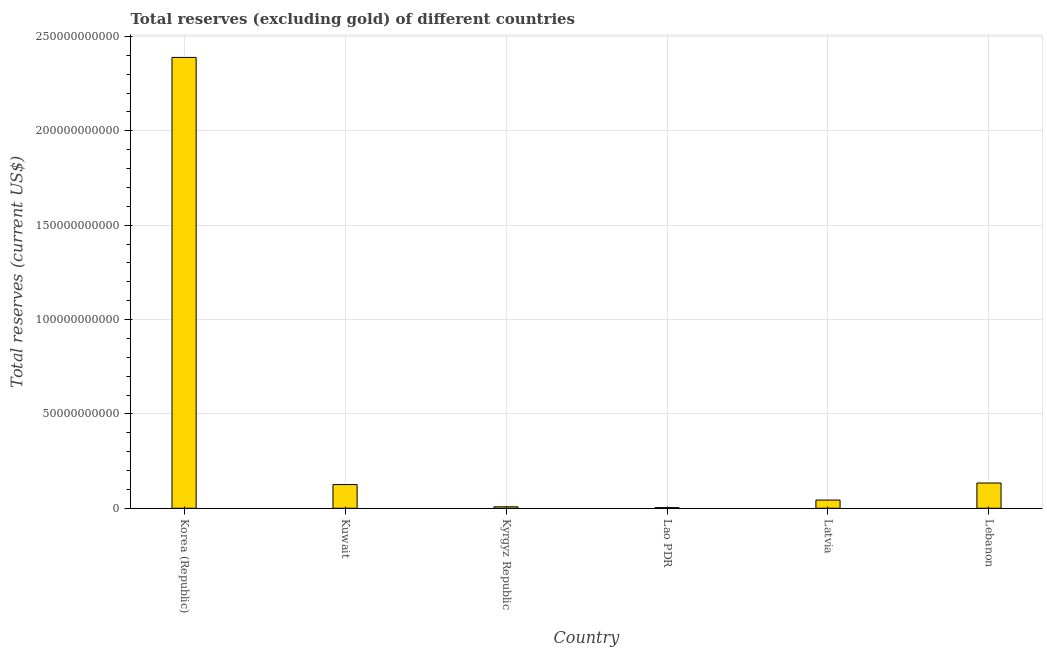Does the graph contain any zero values?
Keep it short and to the point. No. Does the graph contain grids?
Your response must be concise. Yes. What is the title of the graph?
Keep it short and to the point. Total reserves (excluding gold) of different countries. What is the label or title of the Y-axis?
Provide a short and direct response. Total reserves (current US$). What is the total reserves (excluding gold) in Korea (Republic)?
Your response must be concise. 2.39e+11. Across all countries, what is the maximum total reserves (excluding gold)?
Your answer should be very brief. 2.39e+11. Across all countries, what is the minimum total reserves (excluding gold)?
Offer a very short reply. 3.28e+08. In which country was the total reserves (excluding gold) minimum?
Make the answer very short. Lao PDR. What is the sum of the total reserves (excluding gold)?
Your answer should be very brief. 2.70e+11. What is the difference between the total reserves (excluding gold) in Kuwait and Lebanon?
Give a very brief answer. -8.10e+08. What is the average total reserves (excluding gold) per country?
Ensure brevity in your answer.  4.50e+1. What is the median total reserves (excluding gold)?
Your answer should be very brief. 8.46e+09. What is the ratio of the total reserves (excluding gold) in Korea (Republic) to that in Kuwait?
Provide a short and direct response. 19.01. Is the total reserves (excluding gold) in Lao PDR less than that in Latvia?
Provide a succinct answer. Yes. Is the difference between the total reserves (excluding gold) in Korea (Republic) and Lao PDR greater than the difference between any two countries?
Offer a very short reply. Yes. What is the difference between the highest and the second highest total reserves (excluding gold)?
Give a very brief answer. 2.26e+11. Is the sum of the total reserves (excluding gold) in Korea (Republic) and Lao PDR greater than the maximum total reserves (excluding gold) across all countries?
Give a very brief answer. Yes. What is the difference between the highest and the lowest total reserves (excluding gold)?
Make the answer very short. 2.39e+11. How many bars are there?
Give a very brief answer. 6. What is the Total reserves (current US$) in Korea (Republic)?
Offer a terse response. 2.39e+11. What is the Total reserves (current US$) of Kuwait?
Provide a short and direct response. 1.26e+1. What is the Total reserves (current US$) in Kyrgyz Republic?
Make the answer very short. 7.64e+08. What is the Total reserves (current US$) of Lao PDR?
Your response must be concise. 3.28e+08. What is the Total reserves (current US$) in Latvia?
Make the answer very short. 4.35e+09. What is the Total reserves (current US$) in Lebanon?
Give a very brief answer. 1.34e+1. What is the difference between the Total reserves (current US$) in Korea (Republic) and Kuwait?
Your response must be concise. 2.26e+11. What is the difference between the Total reserves (current US$) in Korea (Republic) and Kyrgyz Republic?
Your answer should be very brief. 2.38e+11. What is the difference between the Total reserves (current US$) in Korea (Republic) and Lao PDR?
Ensure brevity in your answer.  2.39e+11. What is the difference between the Total reserves (current US$) in Korea (Republic) and Latvia?
Give a very brief answer. 2.35e+11. What is the difference between the Total reserves (current US$) in Korea (Republic) and Lebanon?
Make the answer very short. 2.26e+11. What is the difference between the Total reserves (current US$) in Kuwait and Kyrgyz Republic?
Your answer should be very brief. 1.18e+1. What is the difference between the Total reserves (current US$) in Kuwait and Lao PDR?
Your response must be concise. 1.22e+1. What is the difference between the Total reserves (current US$) in Kuwait and Latvia?
Keep it short and to the point. 8.21e+09. What is the difference between the Total reserves (current US$) in Kuwait and Lebanon?
Provide a succinct answer. -8.10e+08. What is the difference between the Total reserves (current US$) in Kyrgyz Republic and Lao PDR?
Ensure brevity in your answer.  4.36e+08. What is the difference between the Total reserves (current US$) in Kyrgyz Republic and Latvia?
Provide a succinct answer. -3.59e+09. What is the difference between the Total reserves (current US$) in Kyrgyz Republic and Lebanon?
Your answer should be very brief. -1.26e+1. What is the difference between the Total reserves (current US$) in Lao PDR and Latvia?
Give a very brief answer. -4.02e+09. What is the difference between the Total reserves (current US$) in Lao PDR and Lebanon?
Make the answer very short. -1.30e+1. What is the difference between the Total reserves (current US$) in Latvia and Lebanon?
Ensure brevity in your answer.  -9.02e+09. What is the ratio of the Total reserves (current US$) in Korea (Republic) to that in Kuwait?
Keep it short and to the point. 19.01. What is the ratio of the Total reserves (current US$) in Korea (Republic) to that in Kyrgyz Republic?
Provide a succinct answer. 312.53. What is the ratio of the Total reserves (current US$) in Korea (Republic) to that in Lao PDR?
Offer a very short reply. 727.34. What is the ratio of the Total reserves (current US$) in Korea (Republic) to that in Latvia?
Ensure brevity in your answer.  54.87. What is the ratio of the Total reserves (current US$) in Korea (Republic) to that in Lebanon?
Provide a short and direct response. 17.86. What is the ratio of the Total reserves (current US$) in Kuwait to that in Kyrgyz Republic?
Ensure brevity in your answer.  16.44. What is the ratio of the Total reserves (current US$) in Kuwait to that in Lao PDR?
Provide a short and direct response. 38.26. What is the ratio of the Total reserves (current US$) in Kuwait to that in Latvia?
Give a very brief answer. 2.89. What is the ratio of the Total reserves (current US$) in Kuwait to that in Lebanon?
Keep it short and to the point. 0.94. What is the ratio of the Total reserves (current US$) in Kyrgyz Republic to that in Lao PDR?
Offer a terse response. 2.33. What is the ratio of the Total reserves (current US$) in Kyrgyz Republic to that in Latvia?
Your answer should be compact. 0.18. What is the ratio of the Total reserves (current US$) in Kyrgyz Republic to that in Lebanon?
Your answer should be compact. 0.06. What is the ratio of the Total reserves (current US$) in Lao PDR to that in Latvia?
Ensure brevity in your answer.  0.07. What is the ratio of the Total reserves (current US$) in Lao PDR to that in Lebanon?
Offer a very short reply. 0.03. What is the ratio of the Total reserves (current US$) in Latvia to that in Lebanon?
Offer a very short reply. 0.33. 